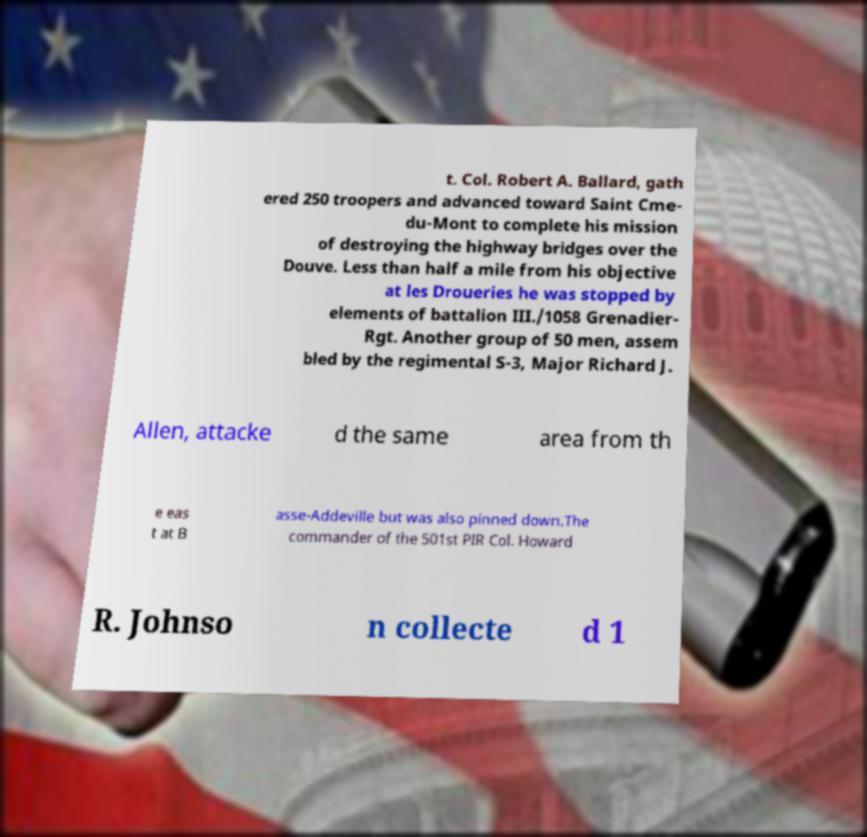What messages or text are displayed in this image? I need them in a readable, typed format. t. Col. Robert A. Ballard, gath ered 250 troopers and advanced toward Saint Cme- du-Mont to complete his mission of destroying the highway bridges over the Douve. Less than half a mile from his objective at les Droueries he was stopped by elements of battalion III./1058 Grenadier- Rgt. Another group of 50 men, assem bled by the regimental S-3, Major Richard J. Allen, attacke d the same area from th e eas t at B asse-Addeville but was also pinned down.The commander of the 501st PIR Col. Howard R. Johnso n collecte d 1 